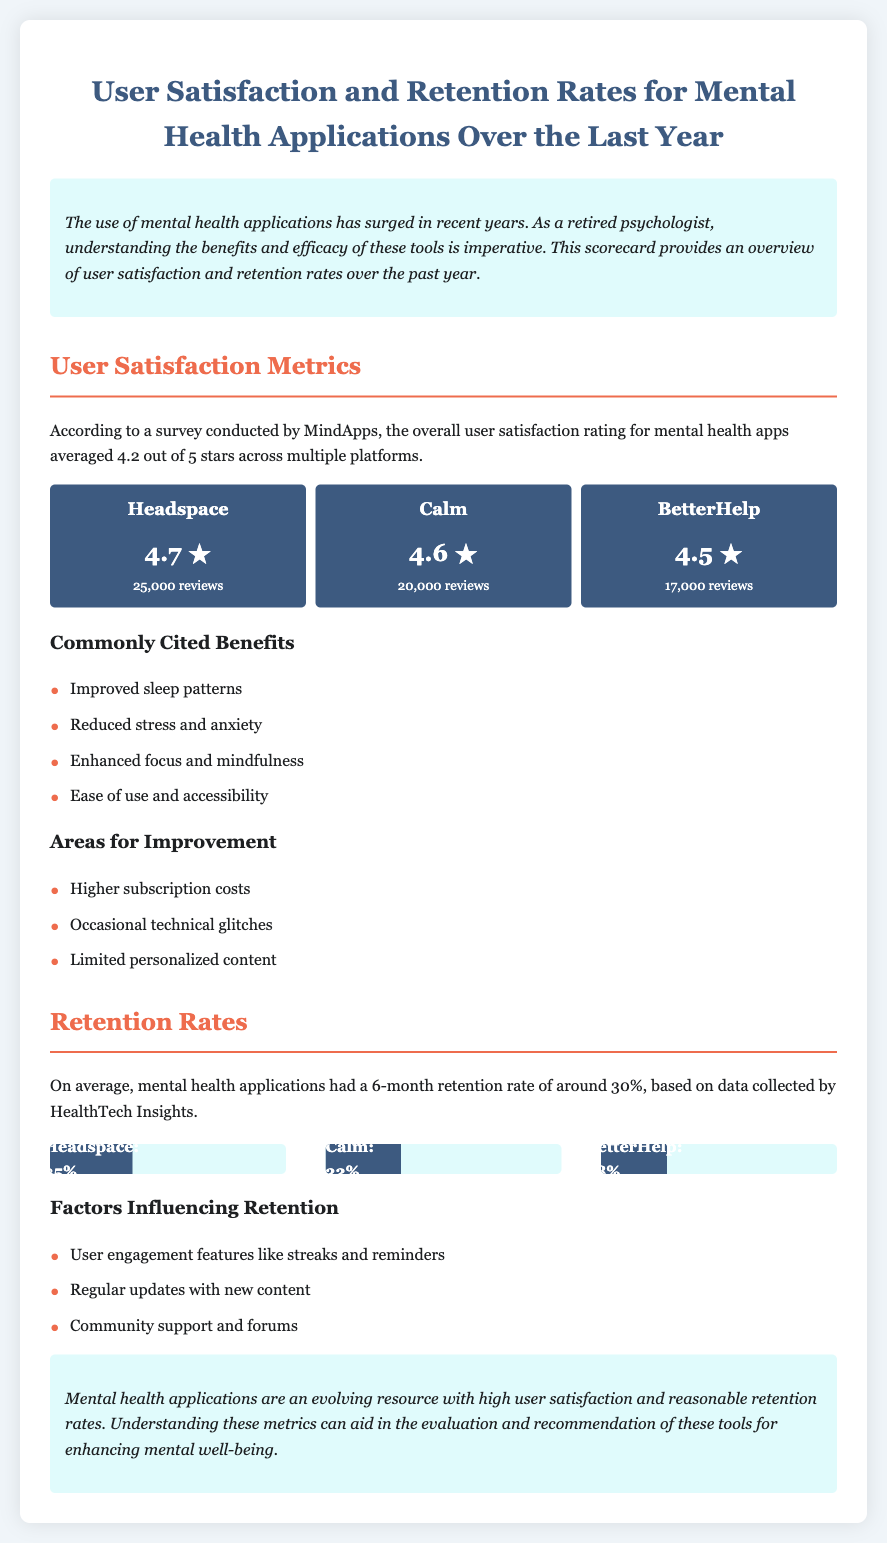what is the overall user satisfaction rating for mental health apps? The overall user satisfaction rating is averaged out from multiple platforms, which is 4.2 out of 5 stars.
Answer: 4.2 out of 5 stars how many reviews does Headspace have? The document states that Headspace has a total of 25,000 reviews.
Answer: 25,000 reviews what is the 6-month retention rate average for mental health applications? The average retention rate for mental health applications over 6 months is stated as around 30%.
Answer: 30% what percentage of retention does Calm have? The document indicates that Calm has a retention rate of 32%.
Answer: 32% name one commonly cited benefit of mental health applications. The document lists several benefits, including improved sleep patterns, reduced stress and anxiety, enhanced focus and mindfulness, and ease of use and accessibility.
Answer: Improved sleep patterns what factor contributes to user retention? Factors influencing retention include user engagement features like streaks and reminders, regular updates with new content, and community support and forums.
Answer: User engagement features which app has the highest user satisfaction rating? The highest user satisfaction rating among the mentioned apps is for Headspace.
Answer: Headspace what are the areas for improvement noted in the document? The document mentions higher subscription costs, occasional technical glitches, and limited personalized content as areas for improvement.
Answer: Higher subscription costs which application has the lowest retention rate mentioned in this report? The document specifies that BetterHelp has the lowest retention rate among the three apps listed, which is 28%.
Answer: BetterHelp 